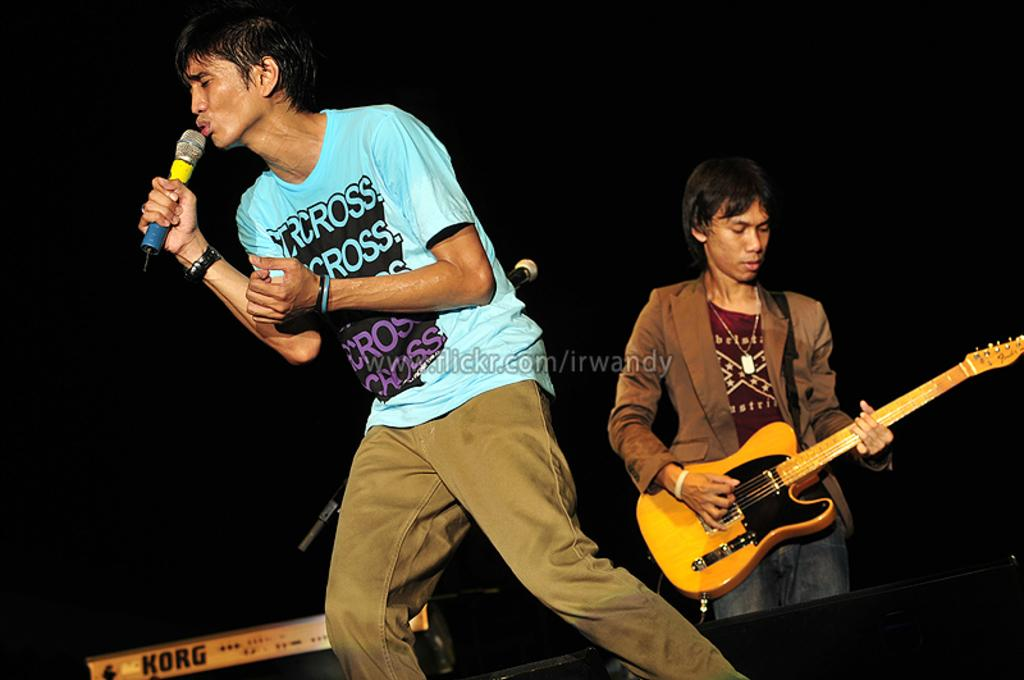How many people are in the image? There are two persons in the image. What are the two people doing in the image? One person is singing with the help of a microphone, and the other person is playing a guitar. What else can be seen in the image related to music? There are musical instruments in the background of the image. What type of cake is being served to the person playing the guitar in the image? There is no cake present in the image; it features two people engaged in musical activities. How many heads can be seen in the image? The image only shows two people, so there are two heads visible. 